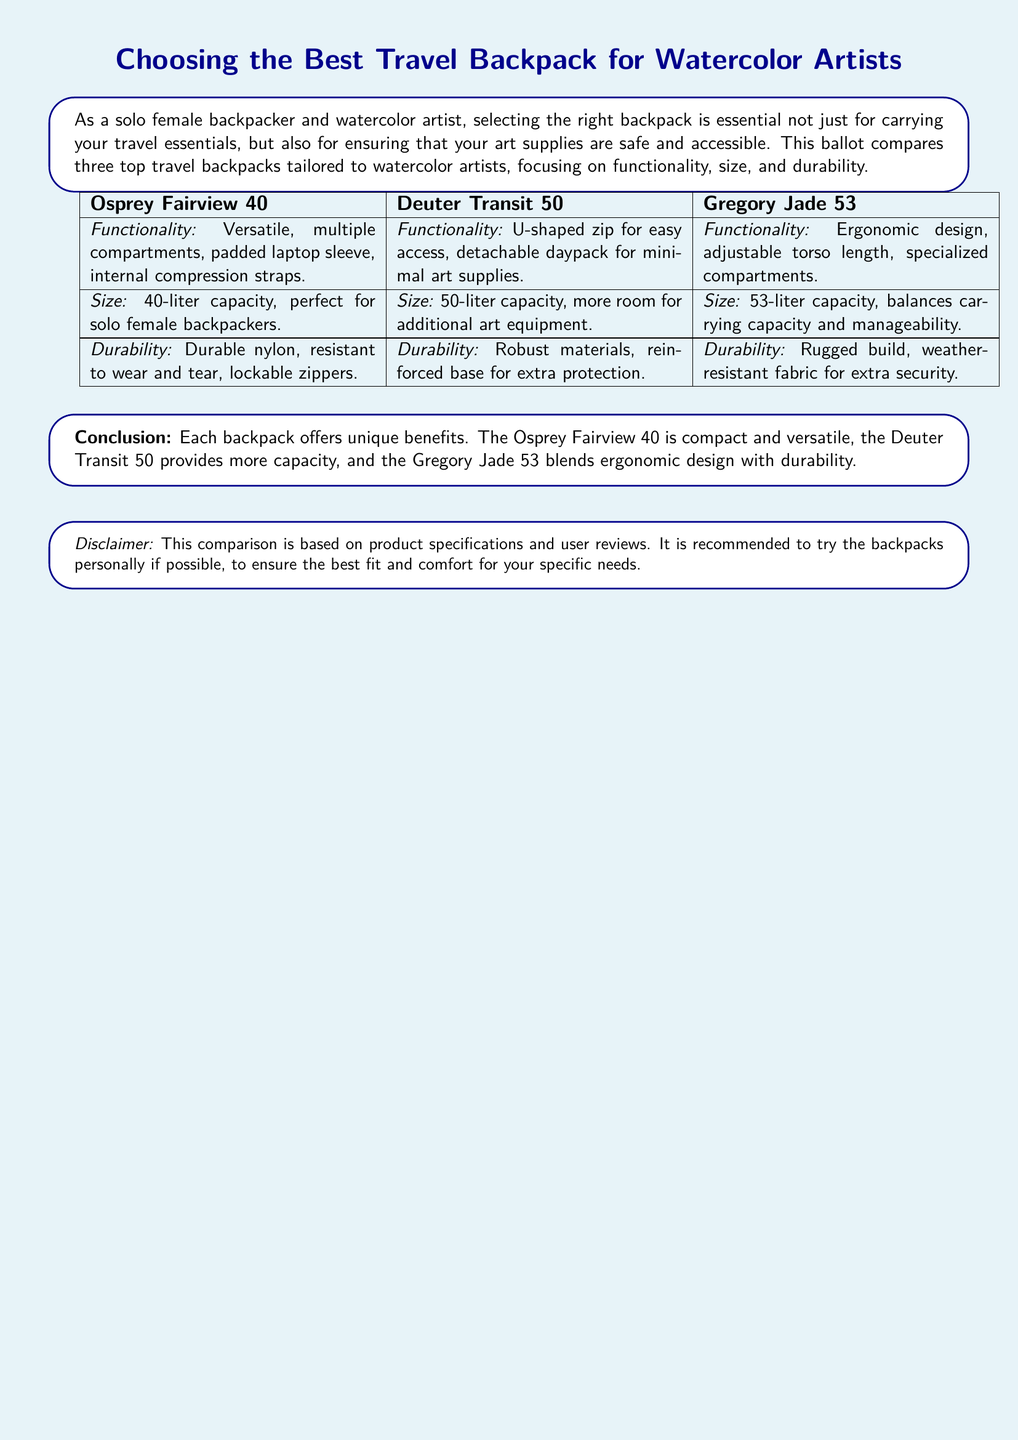What is the capacity of the Osprey Fairview 40? The Osprey Fairview 40 has a capacity of 40 liters.
Answer: 40 liters What feature does the Deuter Transit 50 have for easy access? The Deuter Transit 50 has a U-shaped zip for easy access.
Answer: U-shaped zip Which backpack is noted for its ergonomic design? The Gregory Jade 53 is noted for its ergonomic design.
Answer: Gregory Jade 53 What is a common material used in the backpacks for durability? A common material used is durable nylon.
Answer: Durable nylon How many liters is the capacity of the largest backpack? The largest backpack, Gregory Jade 53, has a capacity of 53 liters.
Answer: 53 liters Which backpack includes a detachable daypack? The Deuter Transit 50 includes a detachable daypack.
Answer: Deuter Transit 50 What type of fabric is the Gregory Jade 53 made from? The Gregory Jade 53 is made from weather-resistant fabric.
Answer: Weather-resistant fabric Which backpack is described as compact and versatile? The Osprey Fairview 40 is described as compact and versatile.
Answer: Osprey Fairview 40 What is recommended in the disclaimer regarding trying the backpacks? The disclaimer recommends trying the backpacks personally if possible.
Answer: Try backpacks personally 